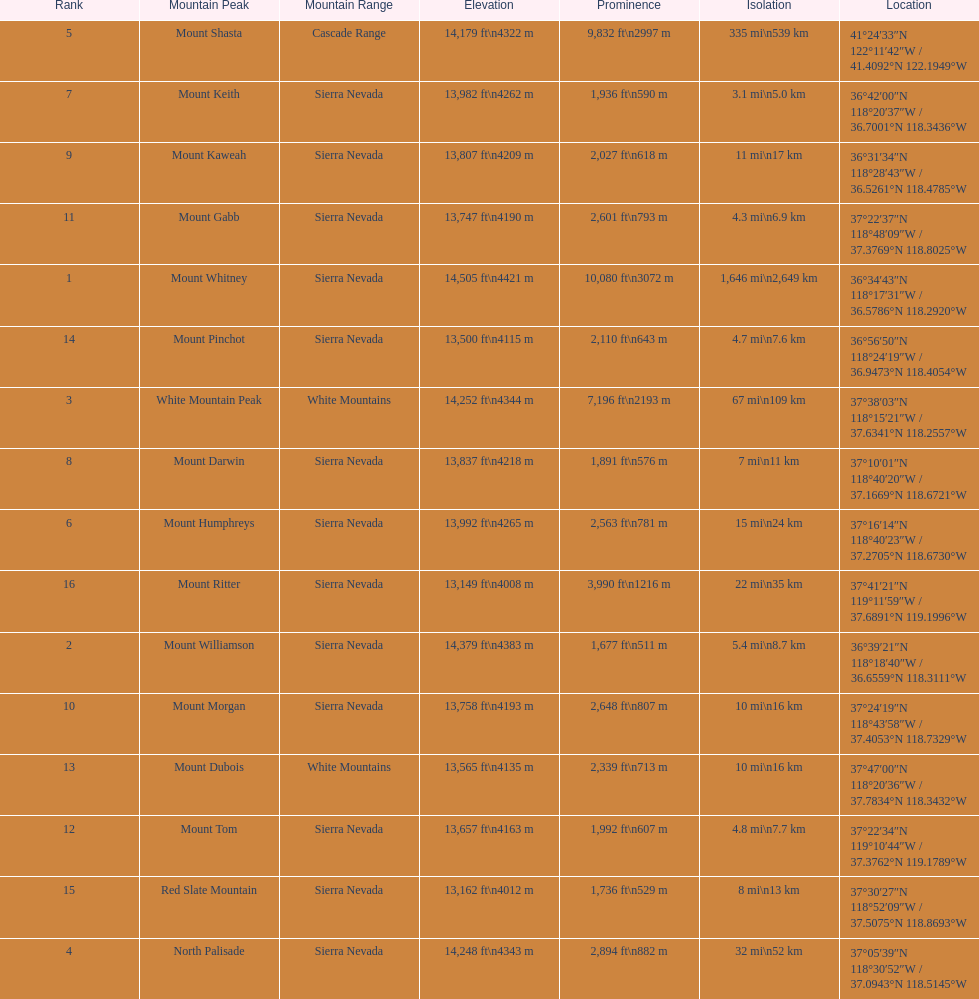What is the only mountain peak listed for the cascade range? Mount Shasta. 